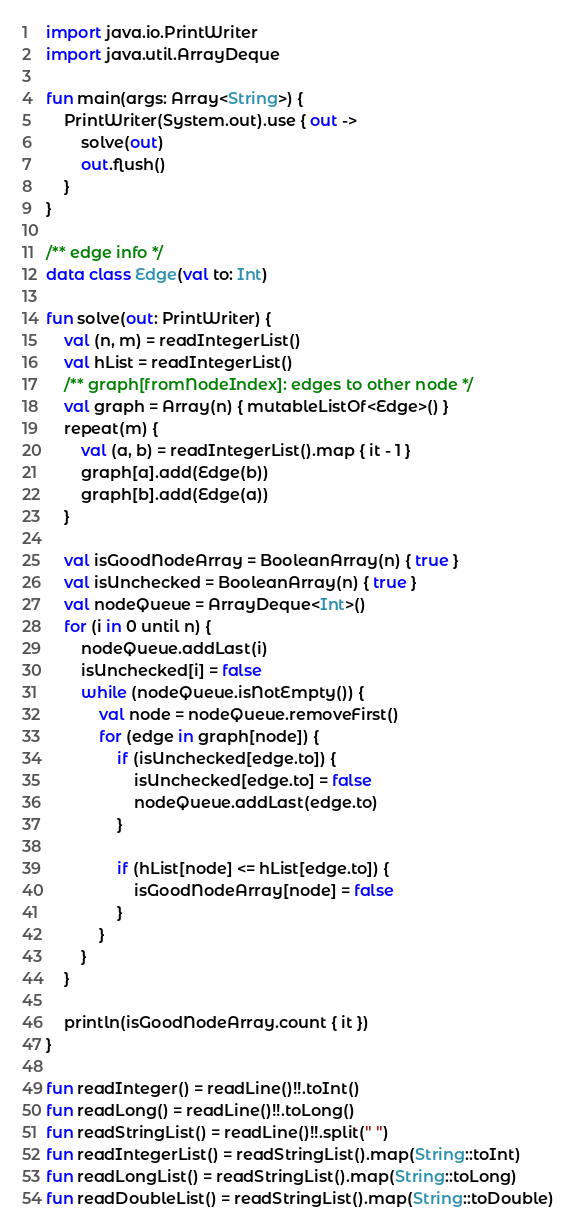Convert code to text. <code><loc_0><loc_0><loc_500><loc_500><_Kotlin_>import java.io.PrintWriter
import java.util.ArrayDeque

fun main(args: Array<String>) {
    PrintWriter(System.out).use { out ->
        solve(out)
        out.flush()
    }
}

/** edge info */
data class Edge(val to: Int)

fun solve(out: PrintWriter) {
    val (n, m) = readIntegerList()
    val hList = readIntegerList()
    /** graph[fromNodeIndex]: edges to other node */
    val graph = Array(n) { mutableListOf<Edge>() }
    repeat(m) {
        val (a, b) = readIntegerList().map { it - 1 }
        graph[a].add(Edge(b))
        graph[b].add(Edge(a))
    }

    val isGoodNodeArray = BooleanArray(n) { true }
    val isUnchecked = BooleanArray(n) { true }
    val nodeQueue = ArrayDeque<Int>()
    for (i in 0 until n) {
        nodeQueue.addLast(i)
        isUnchecked[i] = false
        while (nodeQueue.isNotEmpty()) {
            val node = nodeQueue.removeFirst()
            for (edge in graph[node]) {
                if (isUnchecked[edge.to]) {
                    isUnchecked[edge.to] = false
                    nodeQueue.addLast(edge.to)
                }

                if (hList[node] <= hList[edge.to]) {
                    isGoodNodeArray[node] = false
                }
            }
        }
    }

    println(isGoodNodeArray.count { it })
}

fun readInteger() = readLine()!!.toInt()
fun readLong() = readLine()!!.toLong()
fun readStringList() = readLine()!!.split(" ")
fun readIntegerList() = readStringList().map(String::toInt)
fun readLongList() = readStringList().map(String::toLong)
fun readDoubleList() = readStringList().map(String::toDouble)
</code> 